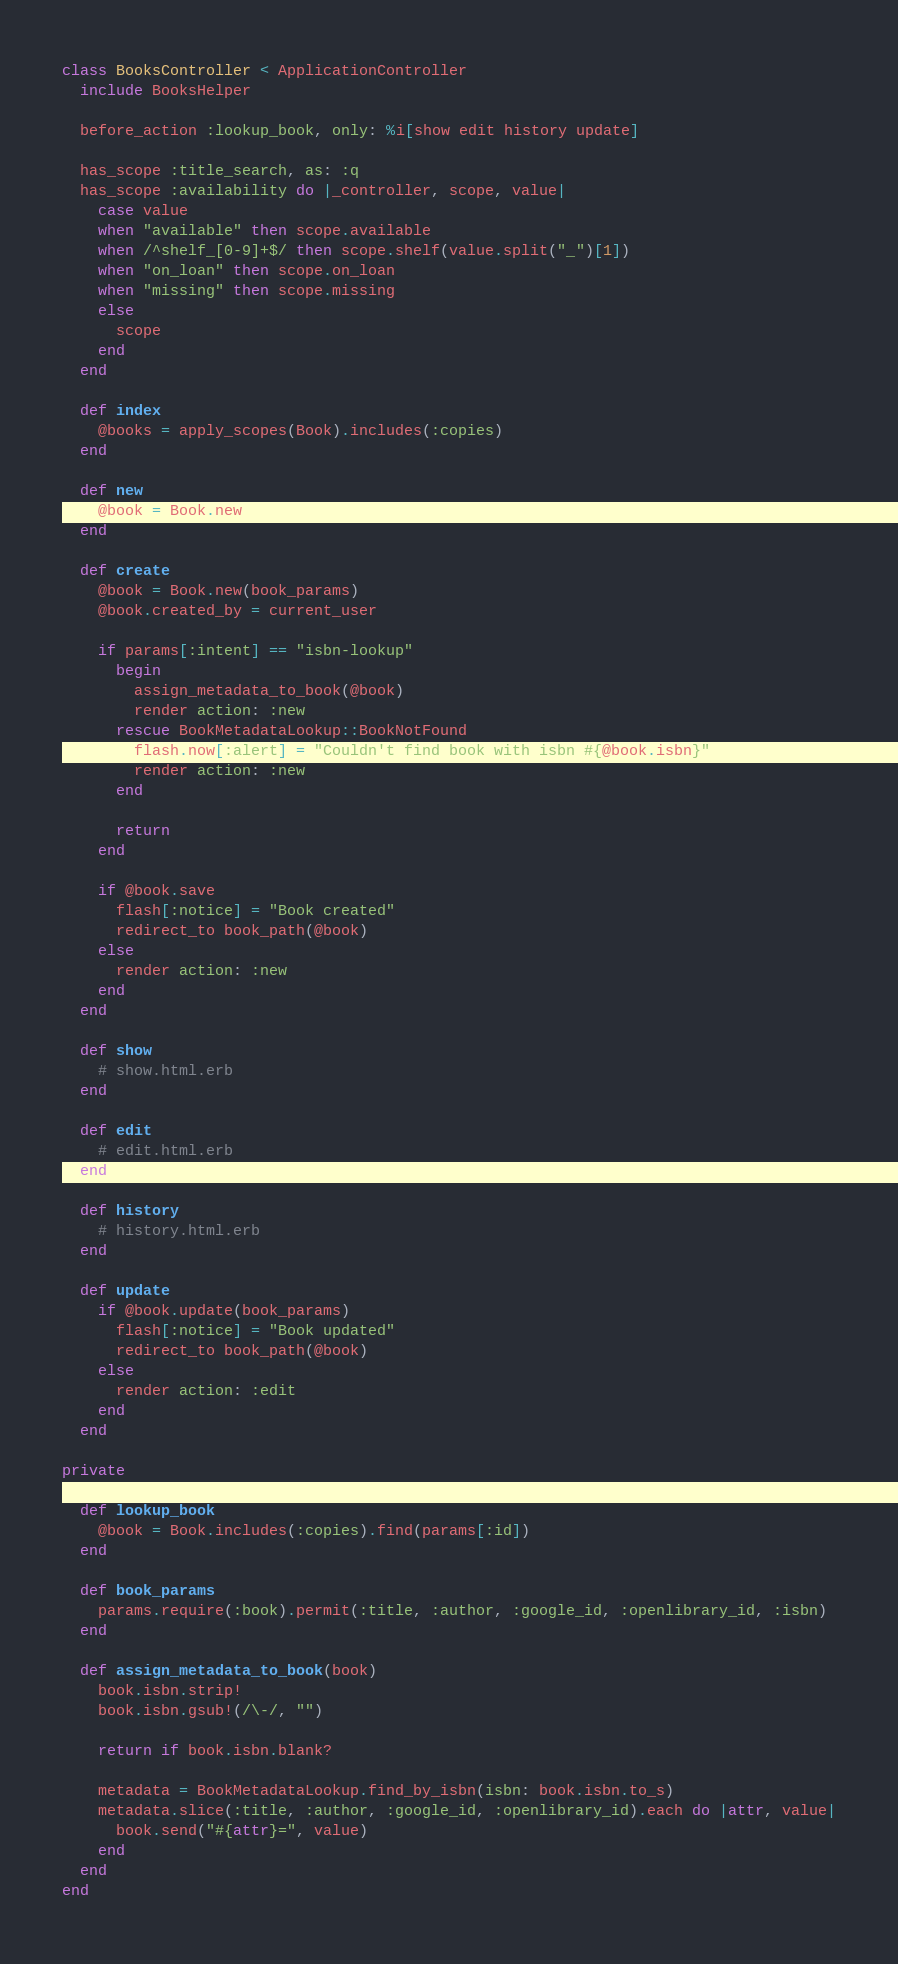Convert code to text. <code><loc_0><loc_0><loc_500><loc_500><_Ruby_>class BooksController < ApplicationController
  include BooksHelper

  before_action :lookup_book, only: %i[show edit history update]

  has_scope :title_search, as: :q
  has_scope :availability do |_controller, scope, value|
    case value
    when "available" then scope.available
    when /^shelf_[0-9]+$/ then scope.shelf(value.split("_")[1])
    when "on_loan" then scope.on_loan
    when "missing" then scope.missing
    else
      scope
    end
  end

  def index
    @books = apply_scopes(Book).includes(:copies)
  end

  def new
    @book = Book.new
  end

  def create
    @book = Book.new(book_params)
    @book.created_by = current_user

    if params[:intent] == "isbn-lookup"
      begin
        assign_metadata_to_book(@book)
        render action: :new
      rescue BookMetadataLookup::BookNotFound
        flash.now[:alert] = "Couldn't find book with isbn #{@book.isbn}"
        render action: :new
      end

      return
    end

    if @book.save
      flash[:notice] = "Book created"
      redirect_to book_path(@book)
    else
      render action: :new
    end
  end

  def show
    # show.html.erb
  end

  def edit
    # edit.html.erb
  end

  def history
    # history.html.erb
  end

  def update
    if @book.update(book_params)
      flash[:notice] = "Book updated"
      redirect_to book_path(@book)
    else
      render action: :edit
    end
  end

private

  def lookup_book
    @book = Book.includes(:copies).find(params[:id])
  end

  def book_params
    params.require(:book).permit(:title, :author, :google_id, :openlibrary_id, :isbn)
  end

  def assign_metadata_to_book(book)
    book.isbn.strip!
    book.isbn.gsub!(/\-/, "")

    return if book.isbn.blank?

    metadata = BookMetadataLookup.find_by_isbn(isbn: book.isbn.to_s)
    metadata.slice(:title, :author, :google_id, :openlibrary_id).each do |attr, value|
      book.send("#{attr}=", value)
    end
  end
end
</code> 